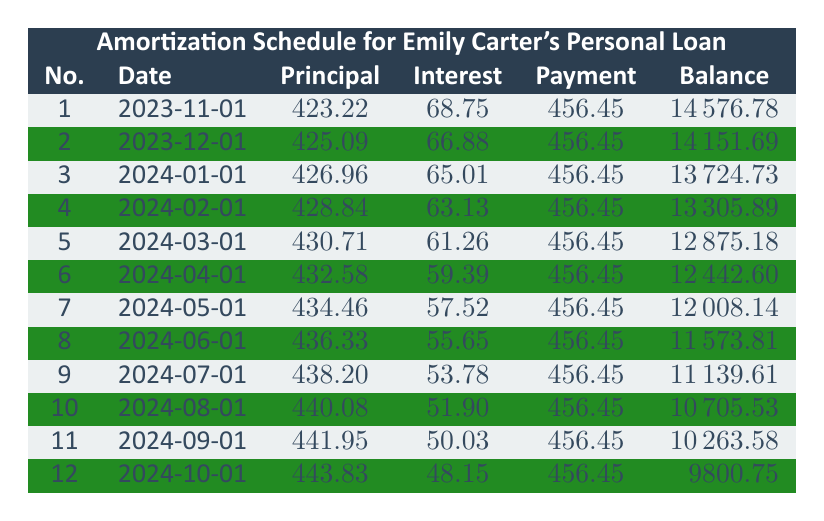What is the monthly payment amount for Emily Carter's personal loan? The table indicates that the "totalPayment" for each month is consistent at 456.45. This is directly found in the loan details section.
Answer: 456.45 What is the principal payment amount for the first month? The first month’s principal payment is explicitly stated as 423.22 in the table.
Answer: 423.22 After three months, what is the remaining balance? To find the remaining balance after three months, look at the "remainingBalance" for the third month, which is 13724.73.
Answer: 13724.73 Is the interest payment for the second month greater than the interest payment for the third month? The interest payment for the second month is 66.88, and for the third month, it is 65.01. Since 66.88 is greater than 65.01, the statement is true.
Answer: Yes What is the total principal paid after the first six months? The total for the principal payments from month 1 to month 6 is the sum: 423.22 + 425.09 + 426.96 + 428.84 + 430.71 + 432.58. Calculating the sum gives 4266.40 as the total principal paid.
Answer: 4266.40 What is the average interest payment over the first 12 months? The interest payments for the first 12 months are: 68.75, 66.88, 65.01, 63.13, 61.26, 59.39, 57.52, 55.65, 53.78, 51.90, 50.03, and 48.15. Summing these gives a total of 360.81, and dividing by 12 gives an average of 30.07.
Answer: 30.07 How much total payment is made after 12 months? The total payment after 12 months is calculated by multiplying the monthly payment by 12: 456.45 * 12 = 5477.40. This shows how much Emily will have paid over the year.
Answer: 5477.40 Does the principal payment increase or decrease over the first 12 months? Observing the principal payments from month 1 to month 12 shows that each month's principal payment increases. For example, it starts at 423.22 and ends at 443.83. Thus, it increases.
Answer: Increases What is the interest amount due for the last payment? The "interestPayment" for the last payment listed (12th month) is 48.15, which is clearly stated in the table.
Answer: 48.15 